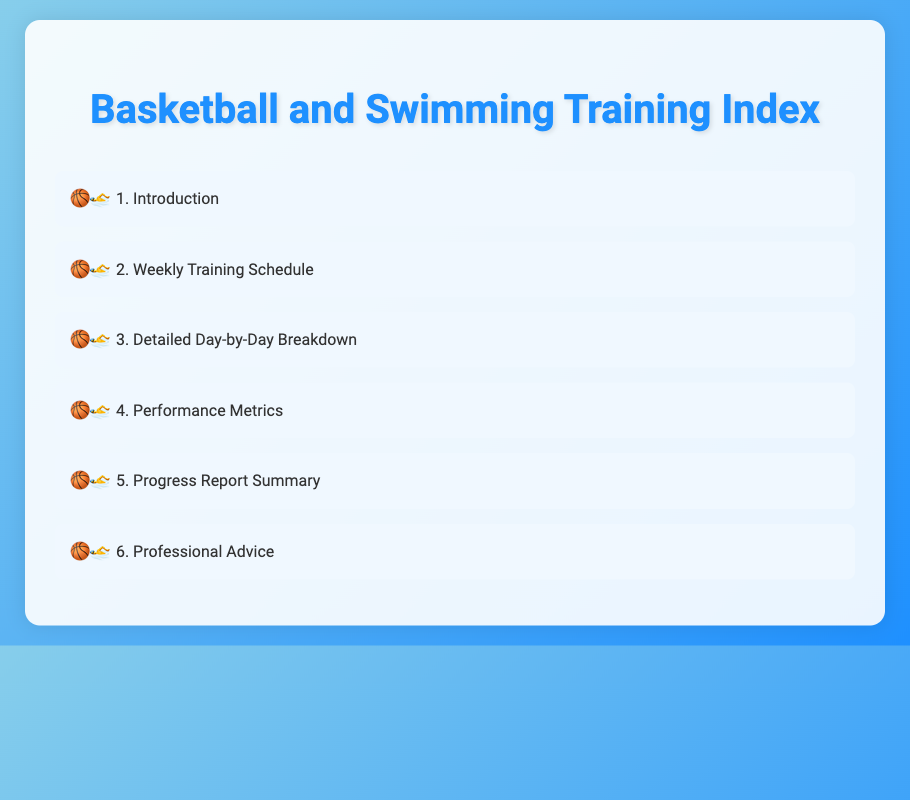What is the title of the document? The title of the document is presented in the header section of the HTML, as indicated by the <title> tag.
Answer: Basketball and Swimming Training Index How many main sections are listed in the index? The number of main sections is determined by counting the list items within the index list.
Answer: 6 What is the first item in the index? The first item in the index is found in the first list item of the index list.
Answer: Introduction Which sport is mentioned first in the document's index? The first sport is indicated by the emoji icons preceding the list items, representing basketball and swimming.
Answer: Basketball What type of detailed information is provided in section 3? The detailed information is implicitly suggested by the section title in the index, focusing on the breakdown of the training schedule across days.
Answer: Day-by-Day Breakdown Which section would likely provide professional advice? The section that would provide professional advice is identified by its title in the index.
Answer: Professional Advice 